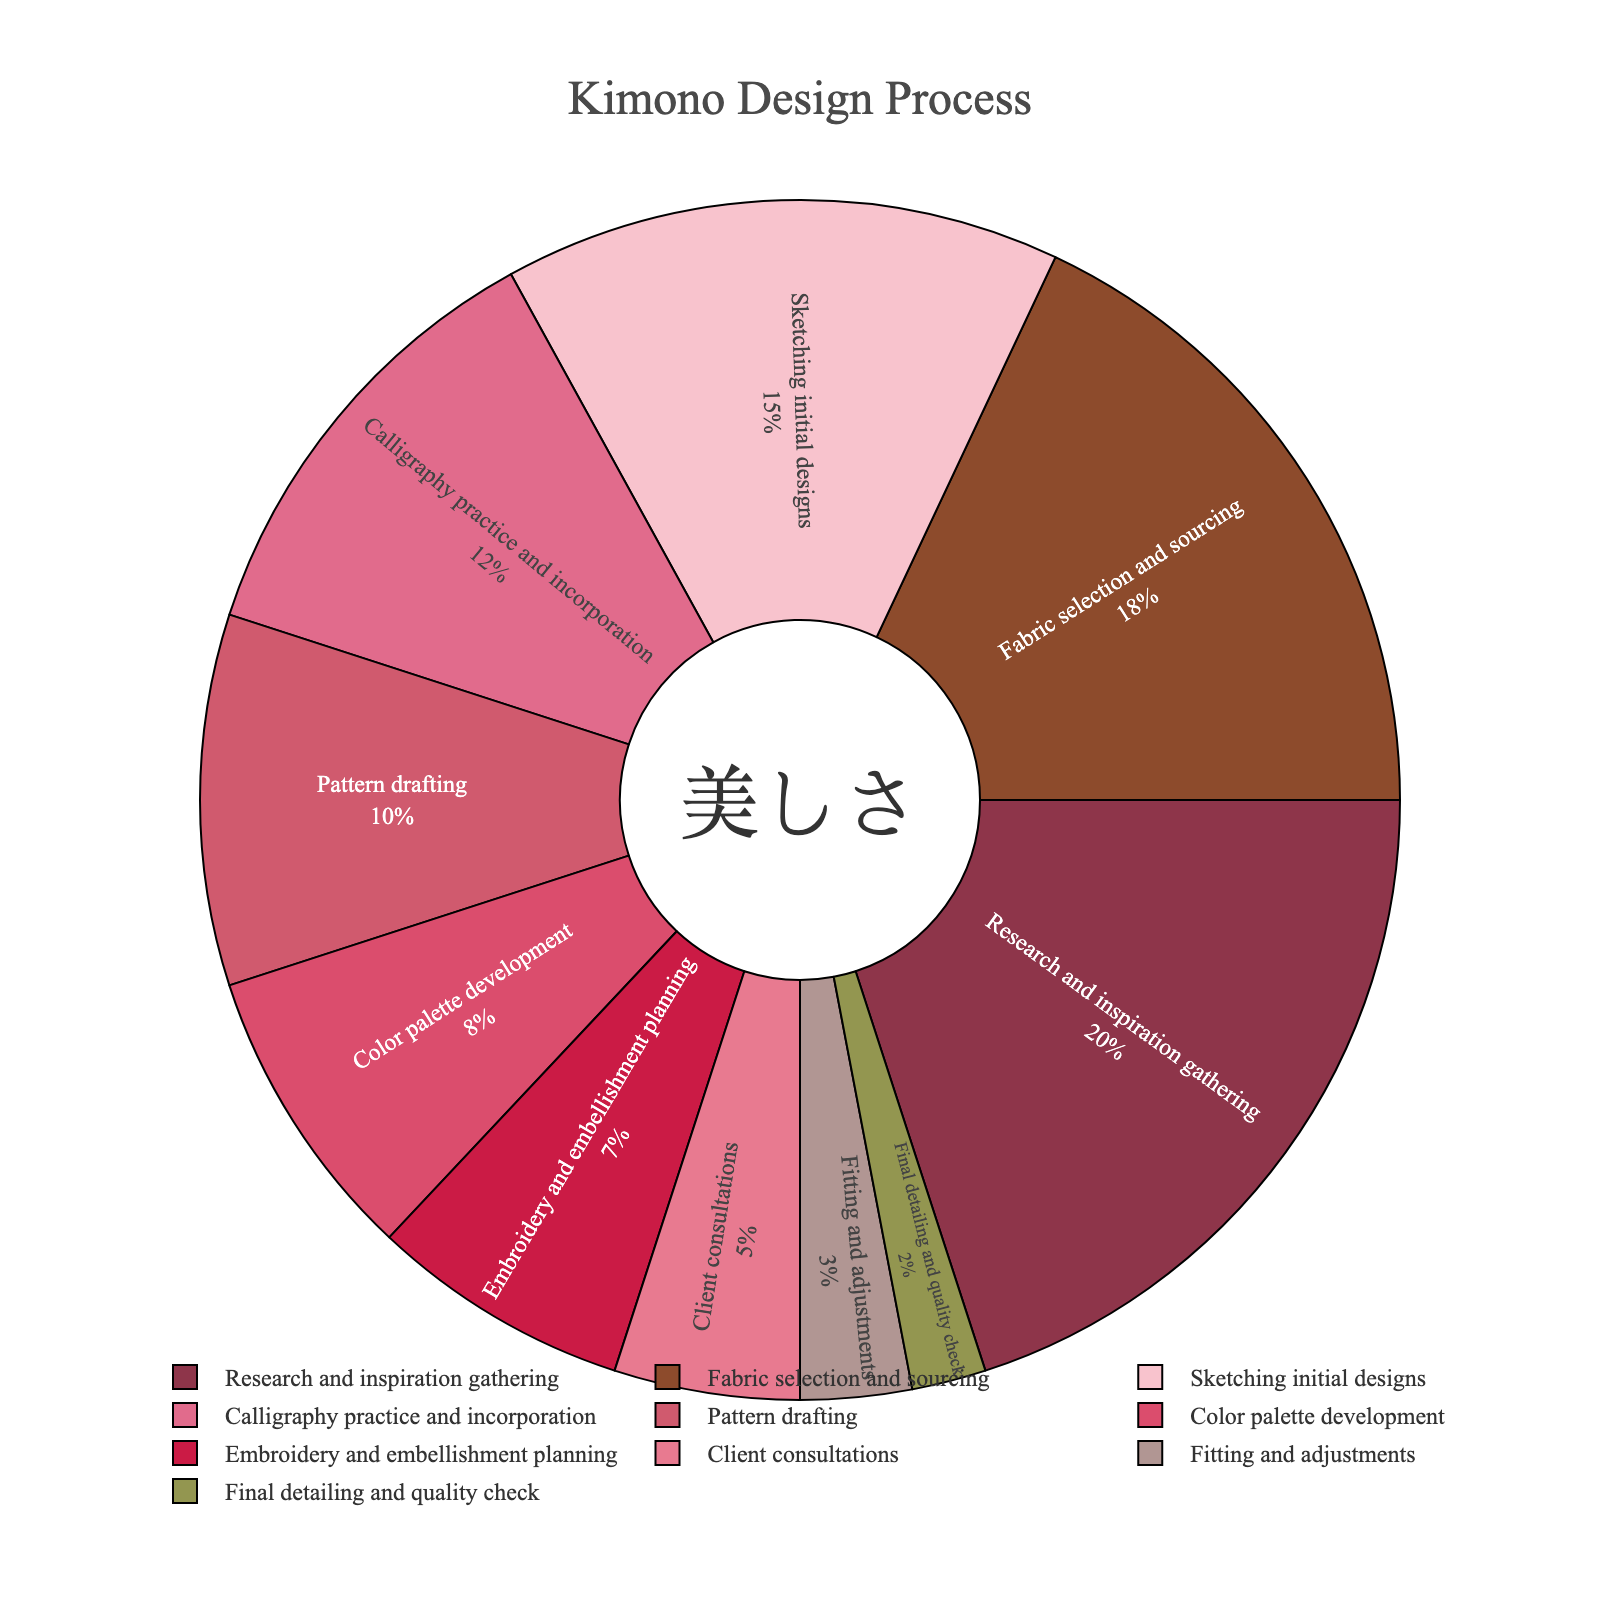Which stage occupies the most time in the kimono design process? By looking at the pie chart, we can see the segment labeled "Research and inspiration gathering" has the largest portion.
Answer: Research and inspiration gathering Which stage has the least time allocated to it? We can see the smallest segment in the pie chart is labeled "Final detailing and quality check."
Answer: Final detailing and quality check How much more time is spent on fabric selection and sourcing compared to calligraphy practice and incorporation? The percentage for fabric selection and sourcing is 18%, while calligraphy practice and incorporation is 12%. The difference is 18% - 12% = 6%.
Answer: 6% What's the combined time percentage spent on sketching initial designs and color palette development? The percentage for sketching initial designs is 15%, and for color palette development is 8%. The sum is 15% + 8% = 23%.
Answer: 23% Is the time spent on client consultations greater than the time spent on pattern drafting? The time for client consultations is 5%, and for pattern drafting is 10%. Since 5% is less than 10%, the answer is no.
Answer: No How does the time allocated to embroidery and embellishment planning compare to fitting and adjustments? Embroidery and embellishment planning takes 7%, while fitting and adjustments take 3%. Therefore, more time is allocated to the former.
Answer: More time is allocated to embroidery and embellishment planning What is the total time spent on pattern drafting, color palette development, and embroidery and embellishment planning? Adding the percentages: pattern drafting (10%), color palette development (8%), and embroidery and embellishment planning (7%) gives 10% + 8% + 7% = 25%.
Answer: 25% Which stages take up more than 15% of the total time? By inspecting the pie chart, we see that "Research and inspiration gathering" (20%) and "Fabric selection and sourcing" (18%) are the segments taking more than 15% of the total time.
Answer: Research and inspiration gathering, Fabric selection and sourcing What visual element is used to highlight the stages in the kimono design process? The segments of the pie chart are distinguished by different colors, along with labels inside them for clarity.
Answer: Colors Between sketching initial designs and calligraphy practice and incorporation, which stage involves more time, and by how much? Sketching initial designs involves 15% and calligraphy practice and incorporation involves 12%. So, sketching initial designs takes 15% - 12% = 3% more time.
Answer: Sketching initial designs, 3% 